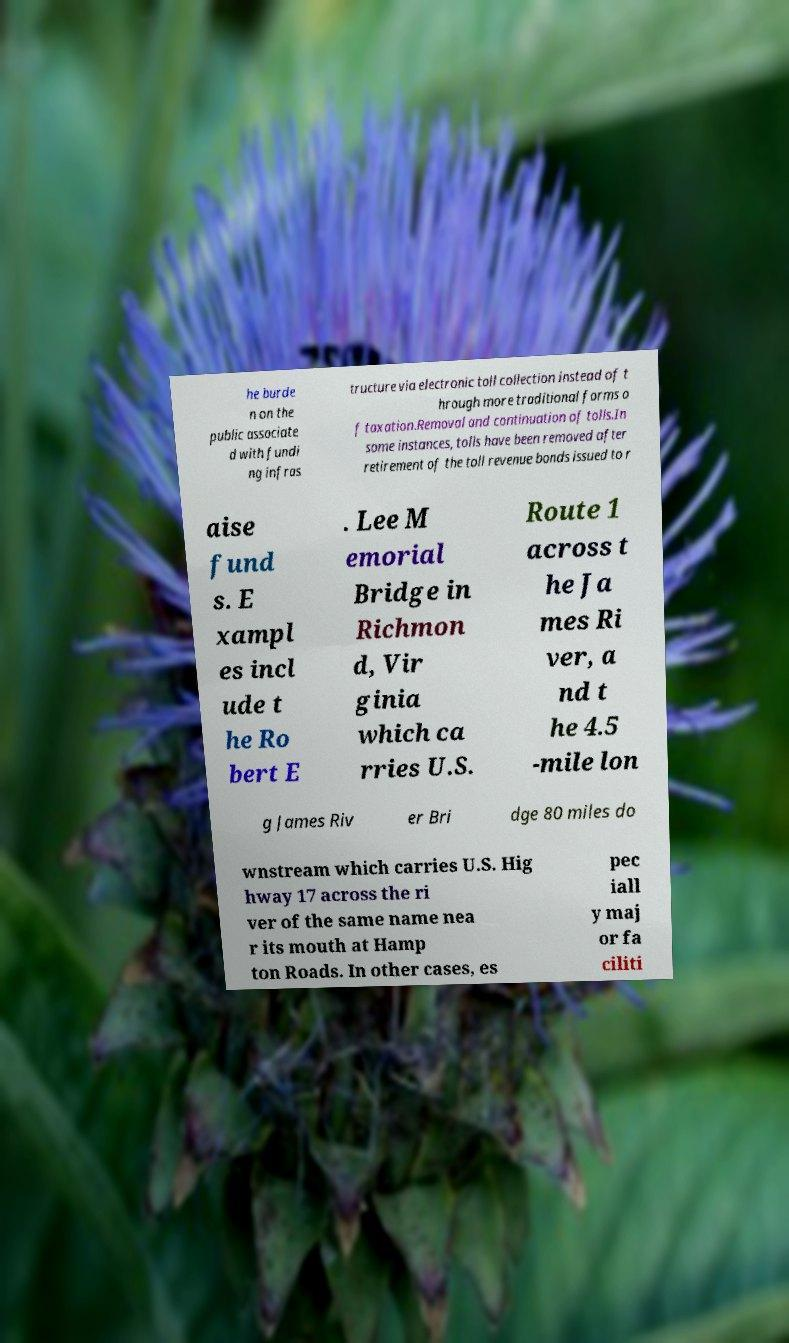I need the written content from this picture converted into text. Can you do that? he burde n on the public associate d with fundi ng infras tructure via electronic toll collection instead of t hrough more traditional forms o f taxation.Removal and continuation of tolls.In some instances, tolls have been removed after retirement of the toll revenue bonds issued to r aise fund s. E xampl es incl ude t he Ro bert E . Lee M emorial Bridge in Richmon d, Vir ginia which ca rries U.S. Route 1 across t he Ja mes Ri ver, a nd t he 4.5 -mile lon g James Riv er Bri dge 80 miles do wnstream which carries U.S. Hig hway 17 across the ri ver of the same name nea r its mouth at Hamp ton Roads. In other cases, es pec iall y maj or fa ciliti 